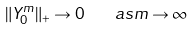<formula> <loc_0><loc_0><loc_500><loc_500>\| Y _ { 0 } ^ { m } \| _ { + } \rightarrow 0 \quad a s m \rightarrow \infty</formula> 